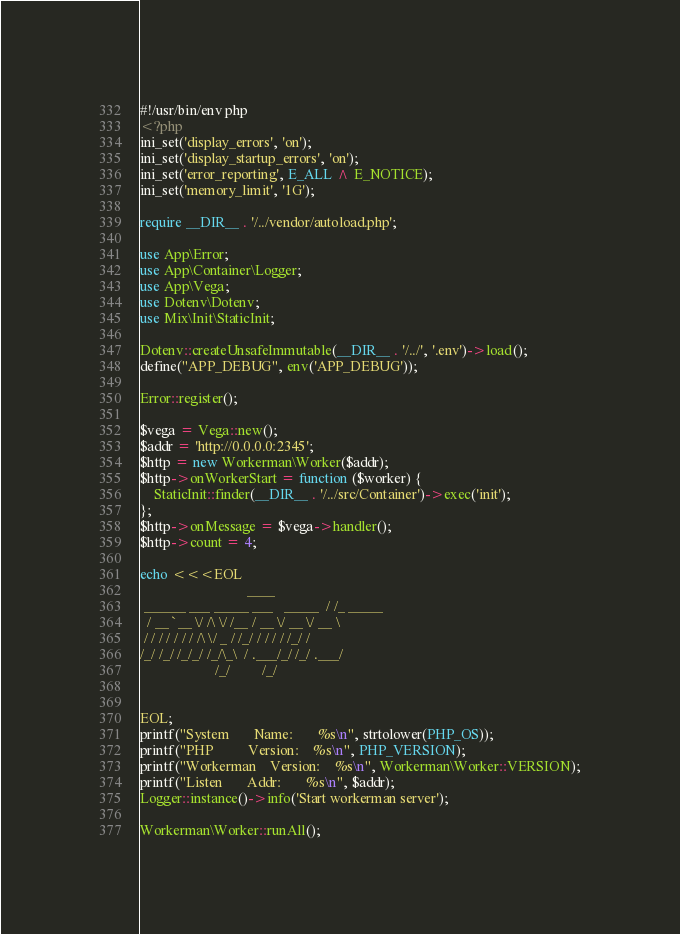Convert code to text. <code><loc_0><loc_0><loc_500><loc_500><_PHP_>#!/usr/bin/env php
<?php
ini_set('display_errors', 'on');
ini_set('display_startup_errors', 'on');
ini_set('error_reporting', E_ALL ^ E_NOTICE);
ini_set('memory_limit', '1G');

require __DIR__ . '/../vendor/autoload.php';

use App\Error;
use App\Container\Logger;
use App\Vega;
use Dotenv\Dotenv;
use Mix\Init\StaticInit;

Dotenv::createUnsafeImmutable(__DIR__ . '/../', '.env')->load();
define("APP_DEBUG", env('APP_DEBUG'));

Error::register();

$vega = Vega::new();
$addr = 'http://0.0.0.0:2345';
$http = new Workerman\Worker($addr);
$http->onWorkerStart = function ($worker) {
    StaticInit::finder(__DIR__ . '/../src/Container')->exec('init');
};
$http->onMessage = $vega->handler();
$http->count = 4;

echo <<<EOL
                              ____
 ______ ___ _____ ___   _____  / /_ _____
  / __ `__ \/ /\ \/ /__ / __ \/ __ \/ __ \
 / / / / / / / /\ \/ _ / /_/ / / / / /_/ /
/_/ /_/ /_/_/ /_/\_\  / .___/_/ /_/ .___/
                     /_/         /_/


EOL;
printf("System       Name:       %s\n", strtolower(PHP_OS));
printf("PHP          Version:    %s\n", PHP_VERSION);
printf("Workerman    Version:    %s\n", Workerman\Worker::VERSION);
printf("Listen       Addr:       %s\n", $addr);
Logger::instance()->info('Start workerman server');

Workerman\Worker::runAll();
</code> 